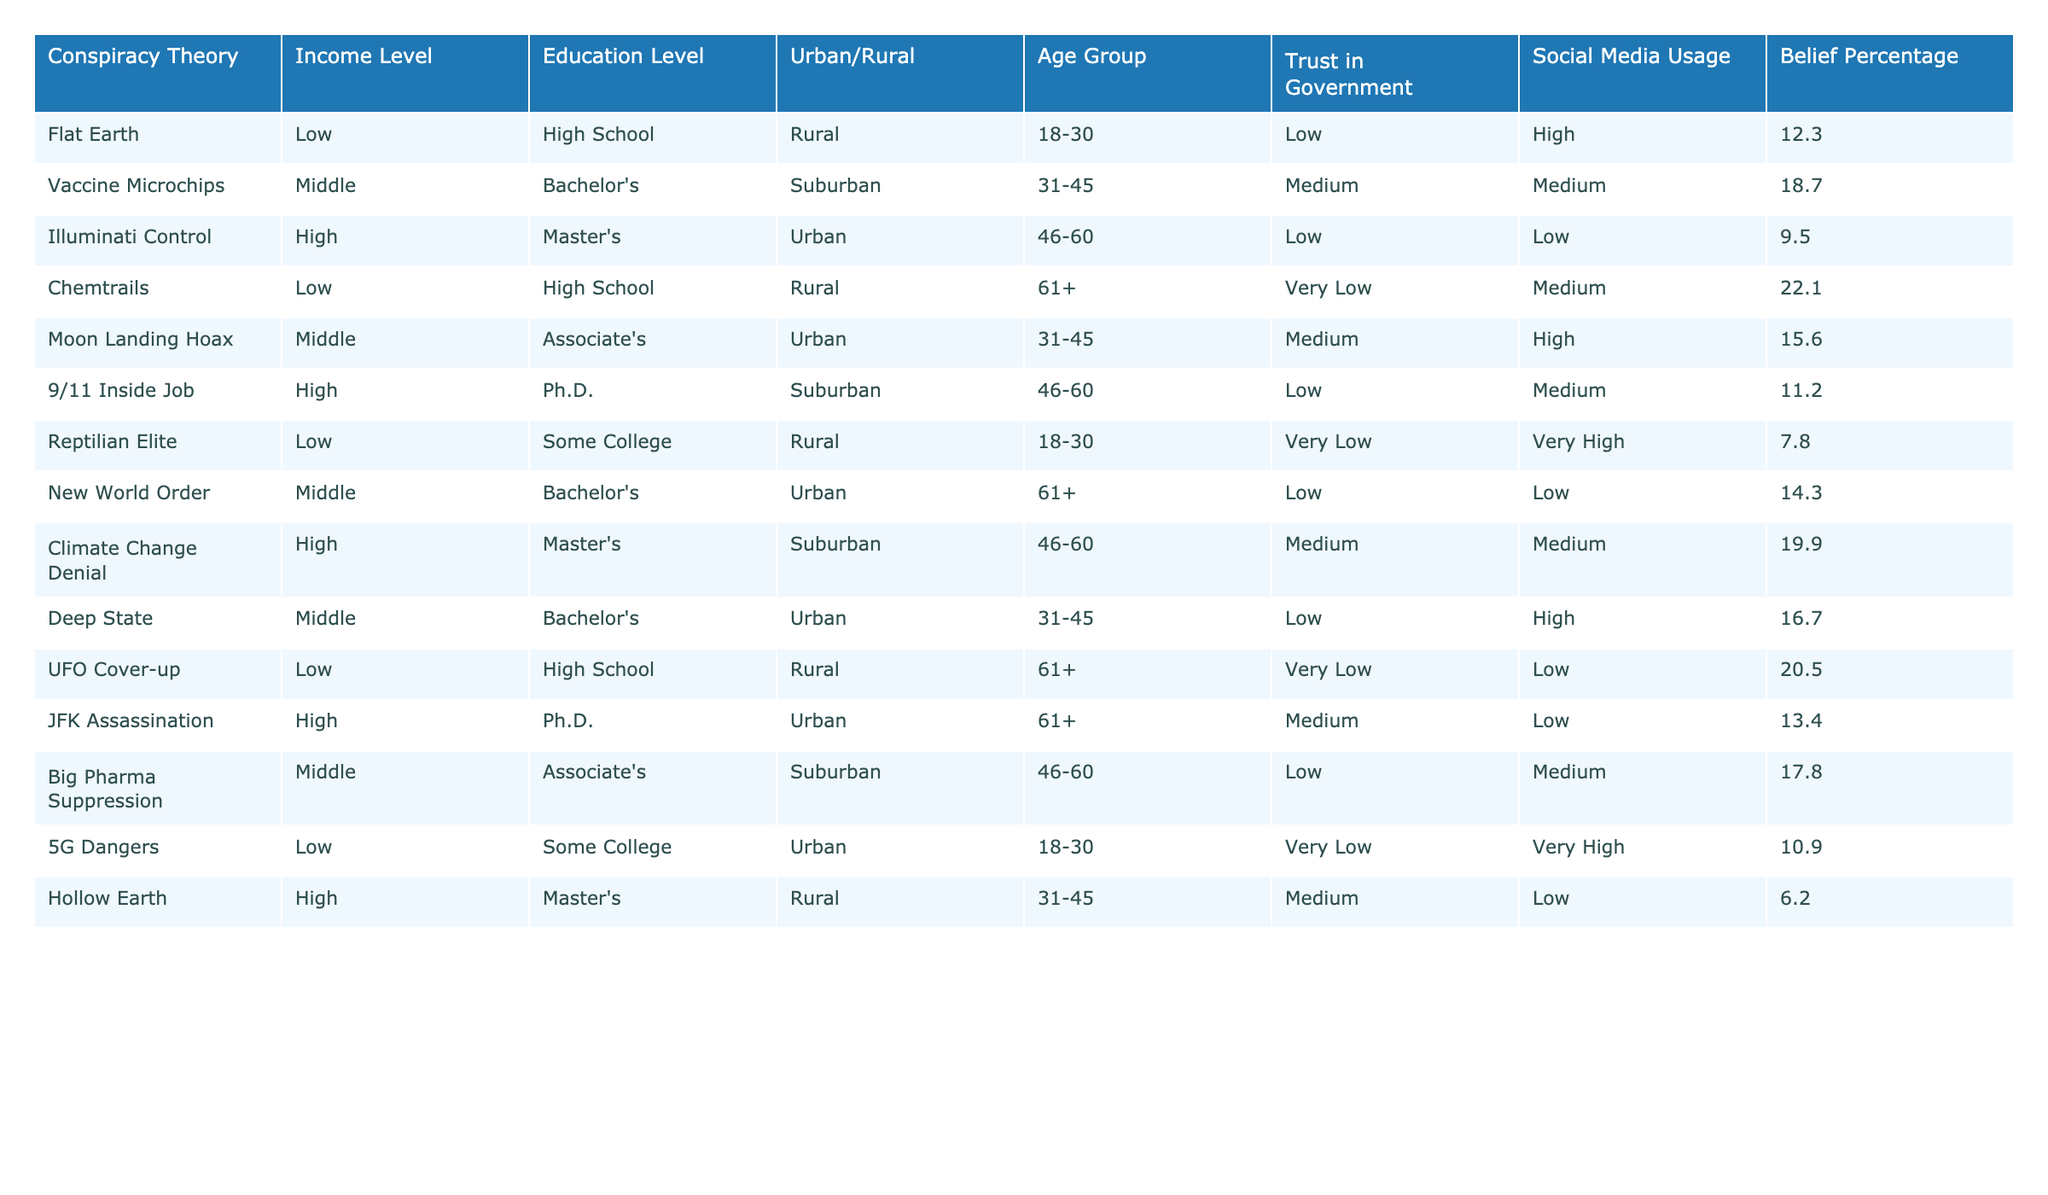What is the belief percentage for the "UFO Cover-up" conspiracy theory? The table indicates that the belief percentage for "UFO Cover-up" is listed in the relevant row. Referring to that, it shows a belief percentage of 20.5.
Answer: 20.5 How many conspiracy theories have a belief percentage above 20? By reviewing the belief percentages in the table, the entries for "Chemtrails" (22.1) and "UFO Cover-up" (20.5) are both above 20, giving a total of two.
Answer: 2 What is the highest belief percentage in the table? Scanning through the belief percentages in the table, "Chemtrails" has the highest percentage at 22.1.
Answer: 22.1 Is there a conspiracy theory with a belief percentage lower than 10? Looking at the belief percentages, all values listed are either above or equal to 7.8, so there is no value lower than 10.
Answer: No What is the average belief percentage of conspiracy theories among the higher income level category? The table shows three conspiracy theories with a high income level: "Illuminati Control" (9.5), "Climate Change Denial" (19.9), and "JFK Assassination" (13.4). Adding these gives a total of 42.8, divided by 3 results in an average of 14.27.
Answer: 14.27 Among the conspiracy theories with a low trust in government, what is the highest belief percentage? The theories with low trust in government are "Flat Earth" (12.3), "Illuminati Control" (9.5), "UFO Cover-up" (20.5), and "9/11 Inside Job" (11.2). The highest belief percentage is from "UFO Cover-up" at 20.5.
Answer: 20.5 What is the belief percentage difference between "Vaccine Microchips" and "Reptilian Elite"? "Vaccine Microchips" has a belief percentage of 18.7 while "Reptilian Elite" is at 7.8. The difference calculated is 18.7 - 7.8 = 10.9.
Answer: 10.9 Is it true that all rural conspiracy theories have a belief percentage below 15? By checking the rural entries, "Flat Earth" (12.3), "Chemtrails" (22.1), and "UFO Cover-up" (20.5) are listed. Since "Chemtrails" and "UFO Cover-up" are above 15, the statement is false.
Answer: No Which age group has a higher average belief percentage: 18-30 or 46-60? The 18-30 group has "Flat Earth" (12.3), "Reptilian Elite" (7.8), and "5G Dangers" (10.9), averaging (12.3 + 7.8 + 10.9) / 3 = 10.33. The 46-60 group has "Vaccine Microchips" (18.7), "9/11 Inside Job" (11.2), "Climate Change Denial" (19.9), averaging (18.7 + 11.2 + 19.9) / 3 = 16.67. Therefore, the 46-60 age group has a higher average.
Answer: 46-60 